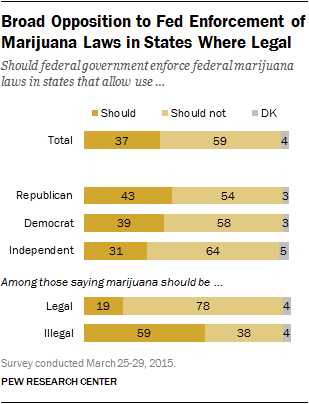Outline some significant characteristics in this image. The difference between the maximum value of "should" and the minimum value of "DK" is 56. The yellow bar represents the value of 'Should I Stay or Should I Go?' 